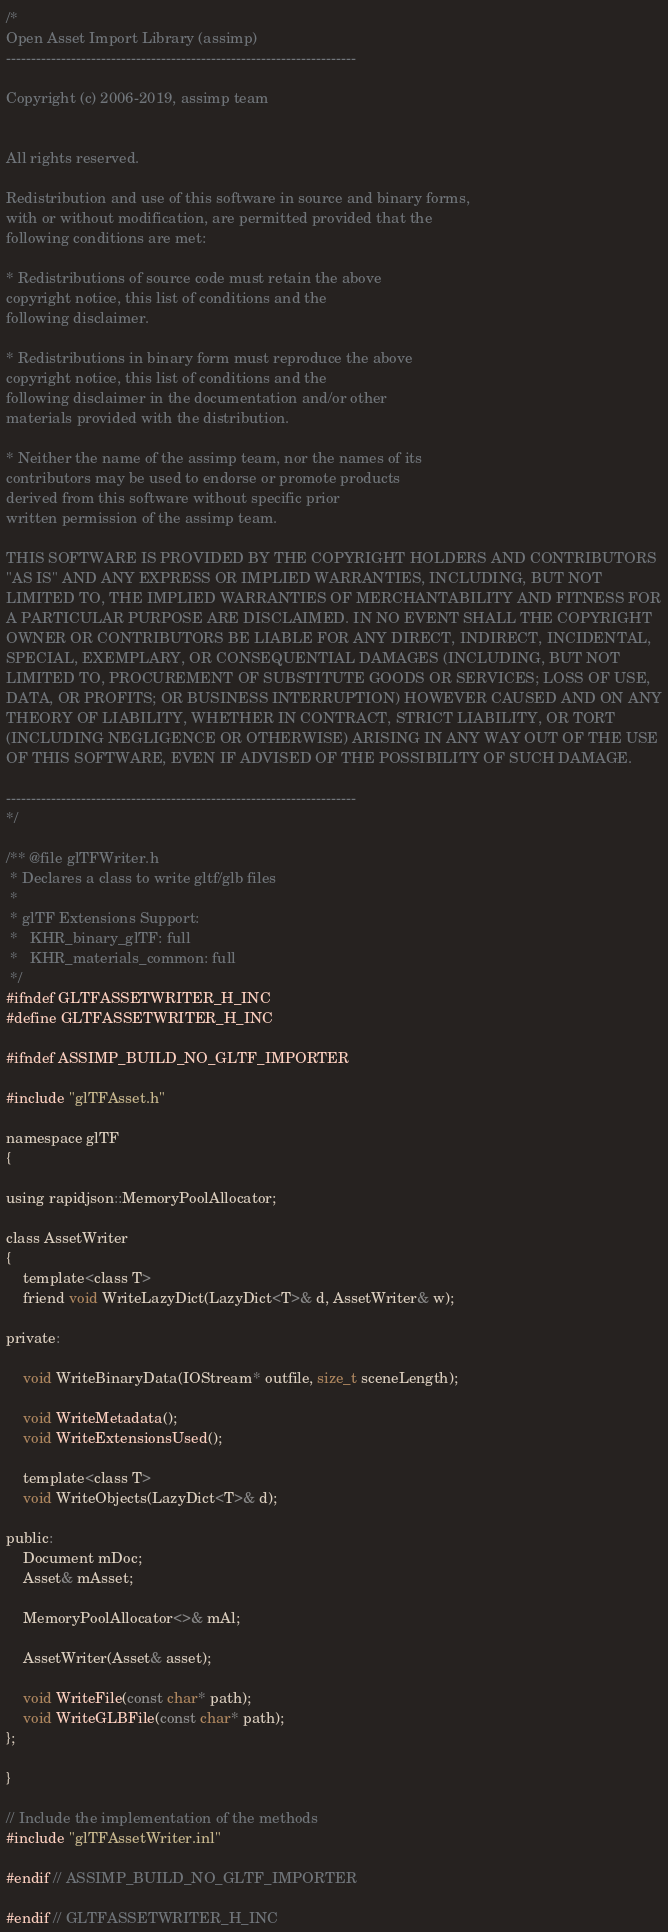<code> <loc_0><loc_0><loc_500><loc_500><_C_>/*
Open Asset Import Library (assimp)
----------------------------------------------------------------------

Copyright (c) 2006-2019, assimp team


All rights reserved.

Redistribution and use of this software in source and binary forms,
with or without modification, are permitted provided that the
following conditions are met:

* Redistributions of source code must retain the above
copyright notice, this list of conditions and the
following disclaimer.

* Redistributions in binary form must reproduce the above
copyright notice, this list of conditions and the
following disclaimer in the documentation and/or other
materials provided with the distribution.

* Neither the name of the assimp team, nor the names of its
contributors may be used to endorse or promote products
derived from this software without specific prior
written permission of the assimp team.

THIS SOFTWARE IS PROVIDED BY THE COPYRIGHT HOLDERS AND CONTRIBUTORS
"AS IS" AND ANY EXPRESS OR IMPLIED WARRANTIES, INCLUDING, BUT NOT
LIMITED TO, THE IMPLIED WARRANTIES OF MERCHANTABILITY AND FITNESS FOR
A PARTICULAR PURPOSE ARE DISCLAIMED. IN NO EVENT SHALL THE COPYRIGHT
OWNER OR CONTRIBUTORS BE LIABLE FOR ANY DIRECT, INDIRECT, INCIDENTAL,
SPECIAL, EXEMPLARY, OR CONSEQUENTIAL DAMAGES (INCLUDING, BUT NOT
LIMITED TO, PROCUREMENT OF SUBSTITUTE GOODS OR SERVICES; LOSS OF USE,
DATA, OR PROFITS; OR BUSINESS INTERRUPTION) HOWEVER CAUSED AND ON ANY
THEORY OF LIABILITY, WHETHER IN CONTRACT, STRICT LIABILITY, OR TORT
(INCLUDING NEGLIGENCE OR OTHERWISE) ARISING IN ANY WAY OUT OF THE USE
OF THIS SOFTWARE, EVEN IF ADVISED OF THE POSSIBILITY OF SUCH DAMAGE.

----------------------------------------------------------------------
*/

/** @file glTFWriter.h
 * Declares a class to write gltf/glb files
 *
 * glTF Extensions Support:
 *   KHR_binary_glTF: full
 *   KHR_materials_common: full
 */
#ifndef GLTFASSETWRITER_H_INC
#define GLTFASSETWRITER_H_INC

#ifndef ASSIMP_BUILD_NO_GLTF_IMPORTER

#include "glTFAsset.h"

namespace glTF
{

using rapidjson::MemoryPoolAllocator;

class AssetWriter
{
    template<class T>
    friend void WriteLazyDict(LazyDict<T>& d, AssetWriter& w);

private:

    void WriteBinaryData(IOStream* outfile, size_t sceneLength);

    void WriteMetadata();
    void WriteExtensionsUsed();

    template<class T>
    void WriteObjects(LazyDict<T>& d);

public:
    Document mDoc;
    Asset& mAsset;

    MemoryPoolAllocator<>& mAl;

    AssetWriter(Asset& asset);

    void WriteFile(const char* path);
    void WriteGLBFile(const char* path);
};

}

// Include the implementation of the methods
#include "glTFAssetWriter.inl"

#endif // ASSIMP_BUILD_NO_GLTF_IMPORTER

#endif // GLTFASSETWRITER_H_INC
</code> 